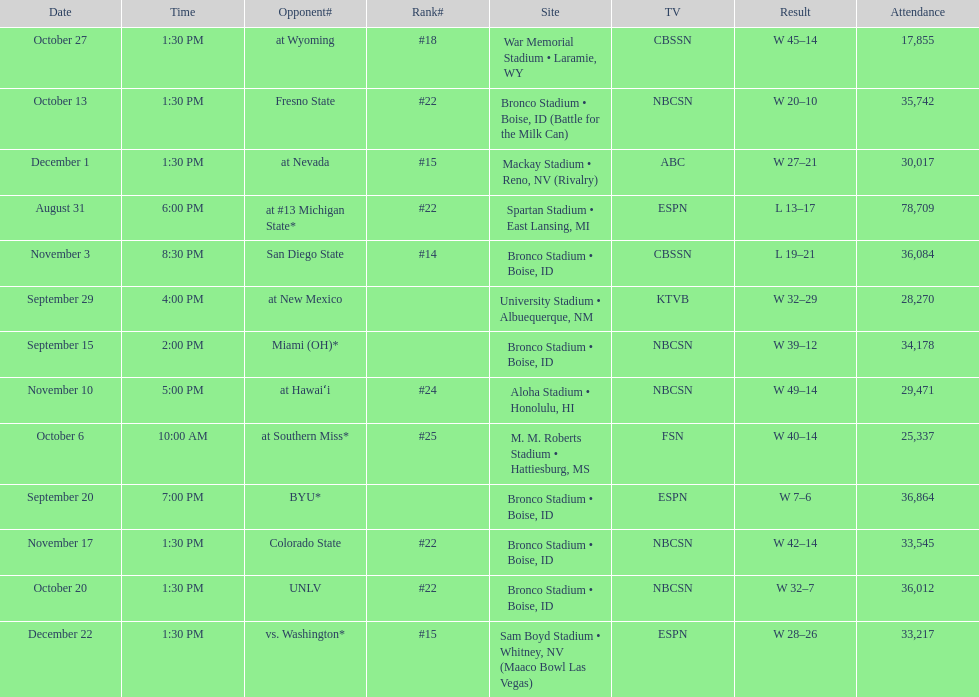Opponent broncos faced next after unlv Wyoming. 